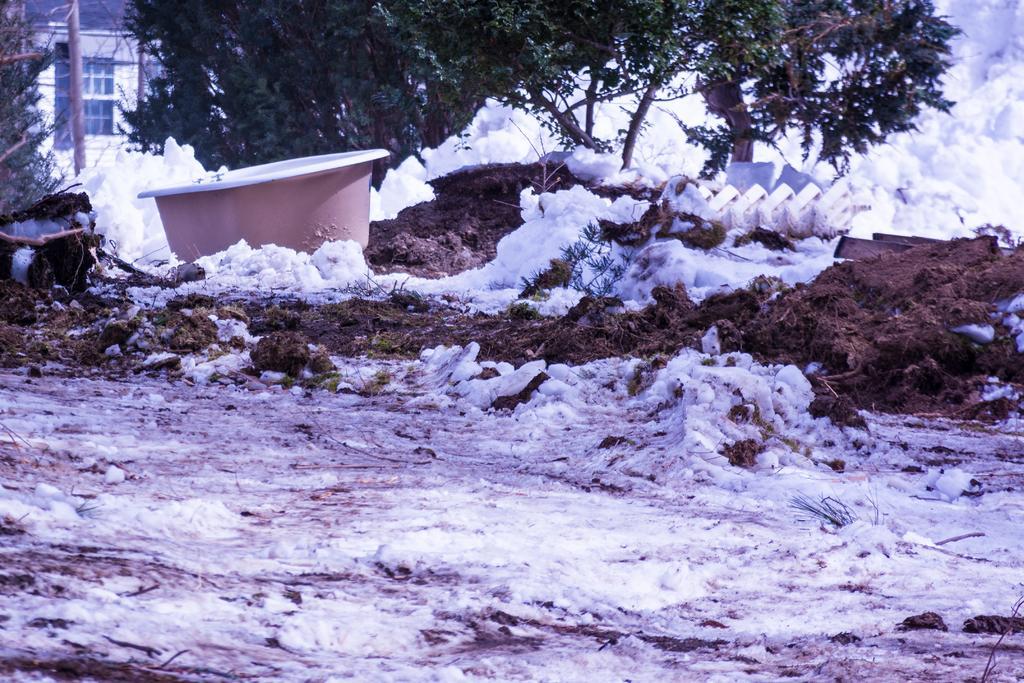How would you summarize this image in a sentence or two? In this image at the bottom there is snow and sand, and on the left side there is one tub. And in the background there is a house, trees and snow and some objects. 